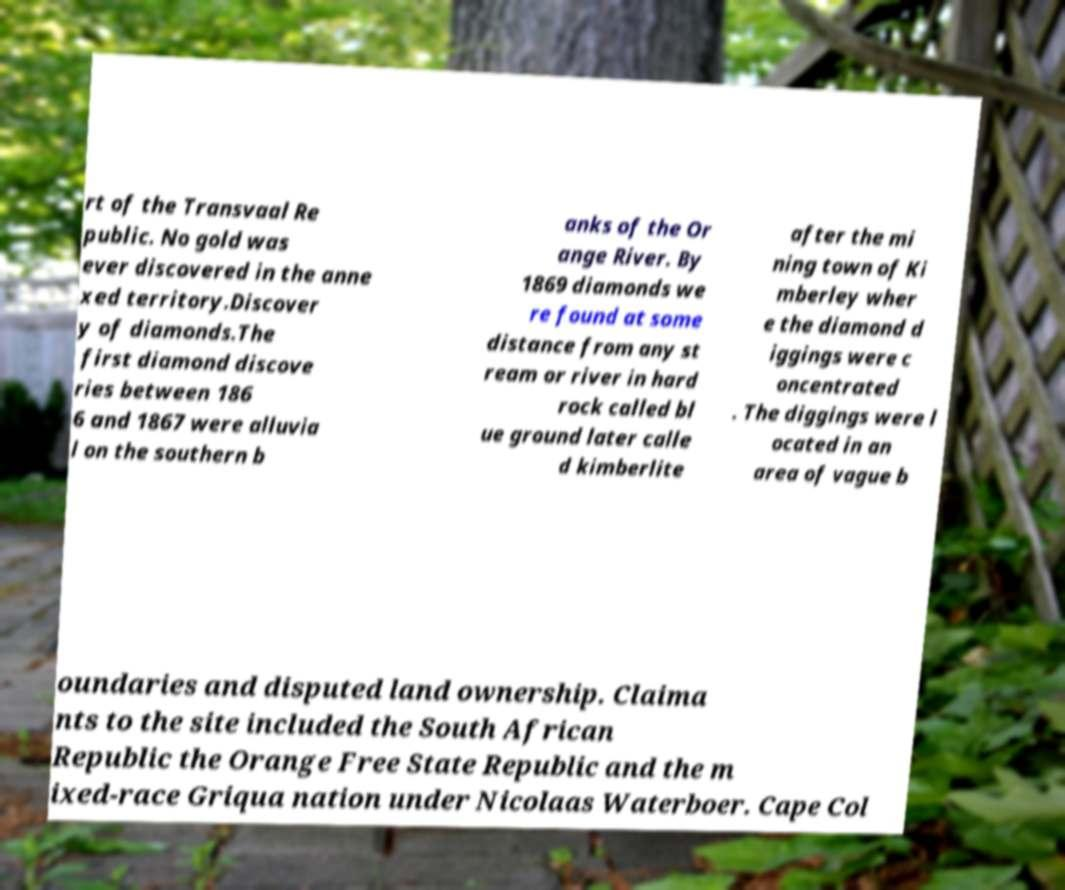Can you read and provide the text displayed in the image?This photo seems to have some interesting text. Can you extract and type it out for me? rt of the Transvaal Re public. No gold was ever discovered in the anne xed territory.Discover y of diamonds.The first diamond discove ries between 186 6 and 1867 were alluvia l on the southern b anks of the Or ange River. By 1869 diamonds we re found at some distance from any st ream or river in hard rock called bl ue ground later calle d kimberlite after the mi ning town of Ki mberley wher e the diamond d iggings were c oncentrated . The diggings were l ocated in an area of vague b oundaries and disputed land ownership. Claima nts to the site included the South African Republic the Orange Free State Republic and the m ixed-race Griqua nation under Nicolaas Waterboer. Cape Col 